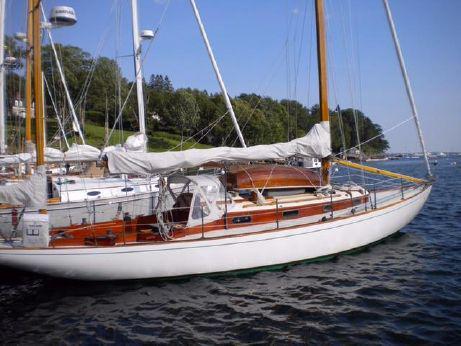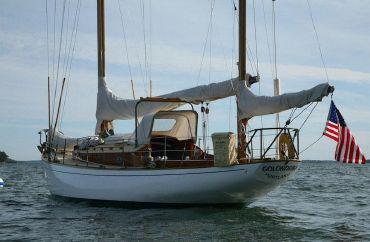The first image is the image on the left, the second image is the image on the right. Examine the images to the left and right. Is the description "Neither boat has its sails up." accurate? Answer yes or no. Yes. 